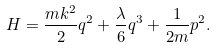<formula> <loc_0><loc_0><loc_500><loc_500>H = \frac { m k ^ { 2 } } { 2 } q ^ { 2 } + \frac { \lambda } { 6 } q ^ { 3 } + \frac { 1 } { 2 m } p ^ { 2 } .</formula> 